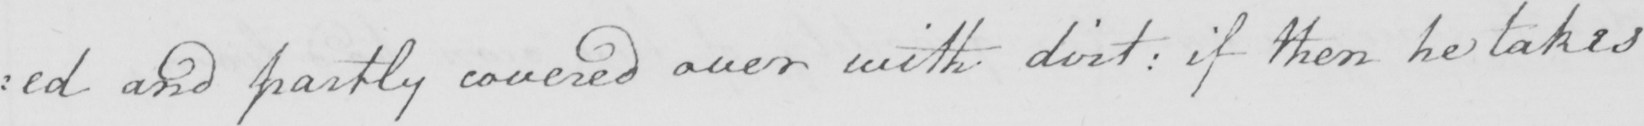Please provide the text content of this handwritten line. : ed and partly covered over with dirt :  if then he takes 